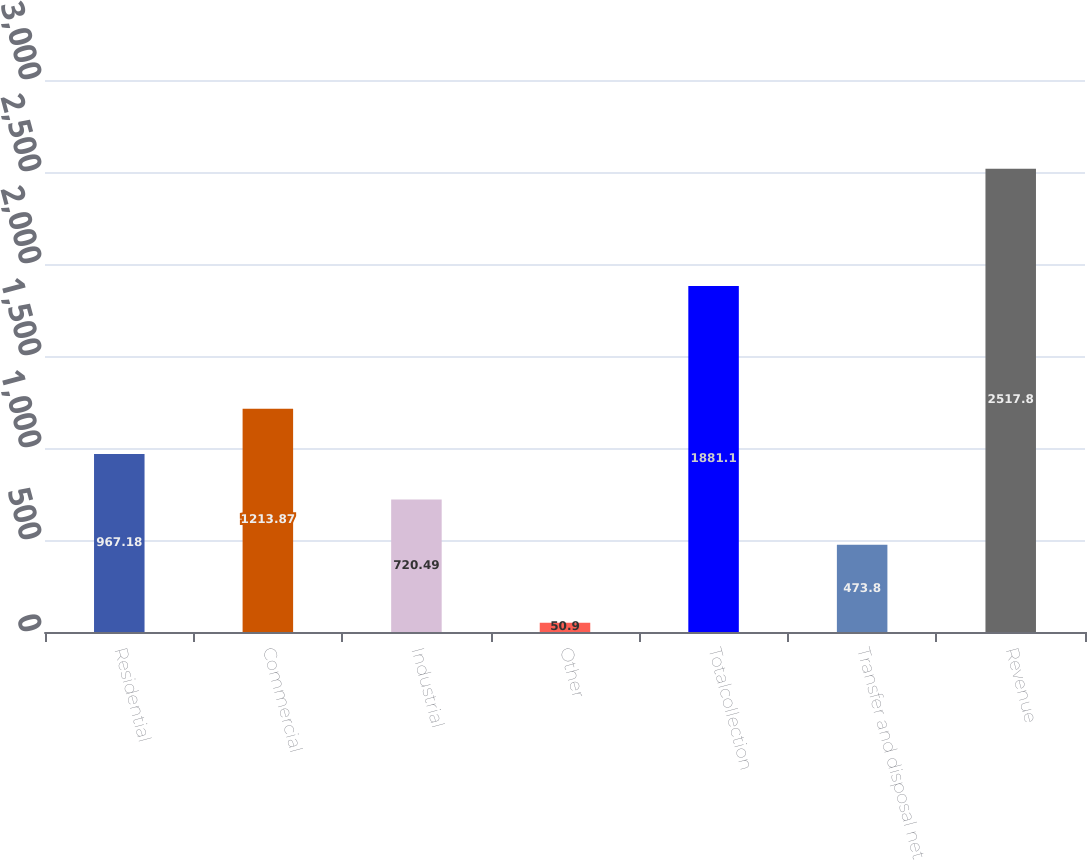Convert chart. <chart><loc_0><loc_0><loc_500><loc_500><bar_chart><fcel>Residential<fcel>Commercial<fcel>Industrial<fcel>Other<fcel>Totalcollection<fcel>Transfer and disposal net<fcel>Revenue<nl><fcel>967.18<fcel>1213.87<fcel>720.49<fcel>50.9<fcel>1881.1<fcel>473.8<fcel>2517.8<nl></chart> 